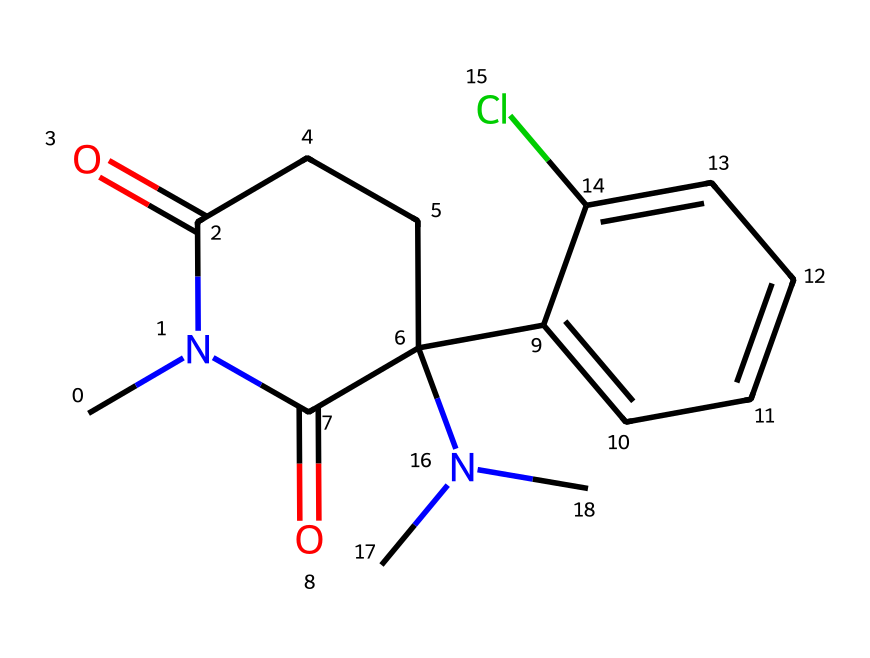What is the molecular formula of ketamine? To determine the molecular formula, count all the atoms in the given SMILES representation. The molecular formula can be deduced to be C13H16ClN2O2 by identifying 13 carbon (C), 16 hydrogen (H), 1 chlorine (Cl), 2 nitrogen (N), and 2 oxygen (O) atoms.
Answer: C13H16ClN2O2 How many rings are present in the structure of ketamine? Analyze the SMILES representation for cyclic structures. The structure contains one fused ring system (the piperidine ring), indicating that there is one ring present in ketamine.
Answer: 1 What functional group is indicated by the “N(C)” notation in the SMILES? The “N(C)” notation denotes a nitrogen atom with a methyl group attached, indicating the presence of a tertiary amine functional group in the molecule. The presence of three groups (two from the structure and one from the N) allows it to be classified as a tertiary amine.
Answer: tertiary amine What type of hybridization is present at the nitrogen atoms in ketamine? Identify the bonding and structure around the nitrogen atoms. The nitrogen attached to three substituents (the methyls and the piperidine) has sp3 hybridization, while the nitrogen involved in a double bond from the carbonyl groups has sp2 hybridization. Thus, both types can be identified.
Answer: sp3 and sp2 What is the geometric configuration of the carbonyl (C=O) functional groups in the ketamine structure? In the ketamine molecule, the carbonyl (C=O) groups are part of a carbon skeleton at the cyclic position, indicating a planar structure around these groups, typically having a linear arrangement due to their double bond. This implies a trapezoidal shape about the 1-3 points.
Answer: planar What type of anesthetic properties does ketamine exhibit? Ketamine is classified as a dissociative anesthetic, which means it induces a trance-like state providing pain relief, sedation, and amnesia. This classification is corroborated by its unique molecular structure and interaction with the NMDA receptor.
Answer: dissociative anesthetic What is the role of the chlorine atom in the ketamine structure? The chlorine atom in ketamine may influence the pharmacological properties and the lipophilicity of the compound. It plays a part in making the drug more effective and modifying the interaction with biological targets, potentially enhancing its anesthetic effects.
Answer: enhances pharmacological properties 